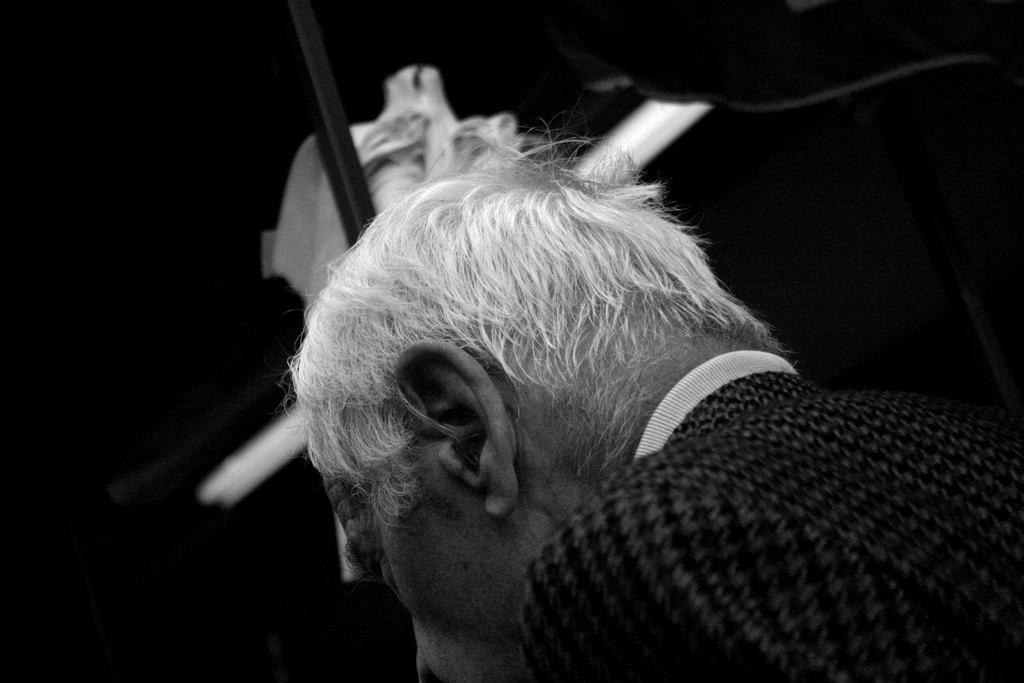Who is present in the image? There is a man in the image. What is the man wearing? The man is wearing a black dress. What objects can be seen in the image besides the man? There are poles or pipes visible in the image. How would you describe the lighting on the left side of the image? The left side of the image appears to be dark. What type of riddle is the man trying to solve in the image? There is no indication in the image that the man is trying to solve a riddle, so it cannot be determined from the picture. 